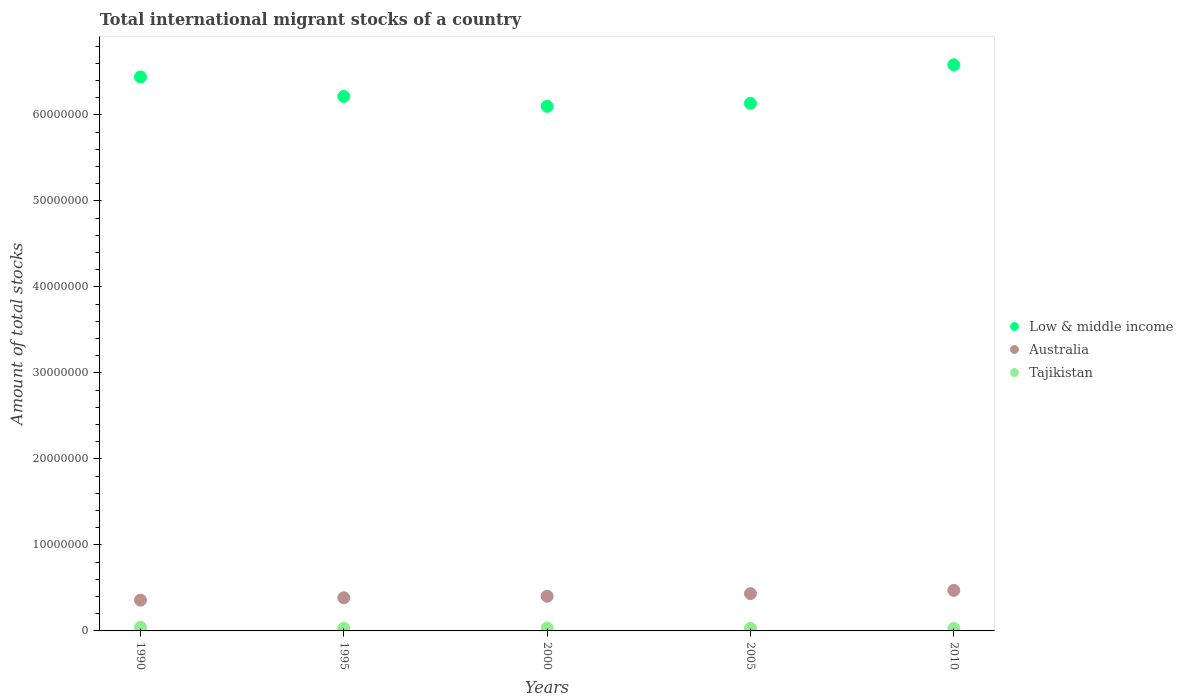Is the number of dotlines equal to the number of legend labels?
Offer a very short reply. Yes. What is the amount of total stocks in in Tajikistan in 1995?
Ensure brevity in your answer.  3.05e+05. Across all years, what is the maximum amount of total stocks in in Tajikistan?
Your answer should be compact. 4.26e+05. Across all years, what is the minimum amount of total stocks in in Australia?
Ensure brevity in your answer.  3.58e+06. In which year was the amount of total stocks in in Low & middle income maximum?
Your response must be concise. 2010. In which year was the amount of total stocks in in Low & middle income minimum?
Ensure brevity in your answer.  2000. What is the total amount of total stocks in in Tajikistan in the graph?
Make the answer very short. 1.65e+06. What is the difference between the amount of total stocks in in Low & middle income in 1995 and that in 2010?
Offer a very short reply. -3.68e+06. What is the difference between the amount of total stocks in in Low & middle income in 2000 and the amount of total stocks in in Australia in 2010?
Provide a short and direct response. 5.63e+07. What is the average amount of total stocks in in Tajikistan per year?
Make the answer very short. 3.30e+05. In the year 2000, what is the difference between the amount of total stocks in in Tajikistan and amount of total stocks in in Australia?
Provide a succinct answer. -3.70e+06. In how many years, is the amount of total stocks in in Australia greater than 46000000?
Give a very brief answer. 0. What is the ratio of the amount of total stocks in in Low & middle income in 1990 to that in 2000?
Give a very brief answer. 1.06. Is the amount of total stocks in in Tajikistan in 2000 less than that in 2010?
Provide a short and direct response. No. Is the difference between the amount of total stocks in in Tajikistan in 2000 and 2010 greater than the difference between the amount of total stocks in in Australia in 2000 and 2010?
Ensure brevity in your answer.  Yes. What is the difference between the highest and the second highest amount of total stocks in in Tajikistan?
Your response must be concise. 9.56e+04. What is the difference between the highest and the lowest amount of total stocks in in Tajikistan?
Keep it short and to the point. 1.42e+05. Is the sum of the amount of total stocks in in Australia in 2000 and 2010 greater than the maximum amount of total stocks in in Tajikistan across all years?
Give a very brief answer. Yes. Is it the case that in every year, the sum of the amount of total stocks in in Tajikistan and amount of total stocks in in Low & middle income  is greater than the amount of total stocks in in Australia?
Ensure brevity in your answer.  Yes. Does the amount of total stocks in in Low & middle income monotonically increase over the years?
Offer a terse response. No. Is the amount of total stocks in in Tajikistan strictly greater than the amount of total stocks in in Low & middle income over the years?
Provide a succinct answer. No. How many dotlines are there?
Give a very brief answer. 3. Does the graph contain grids?
Offer a very short reply. No. How many legend labels are there?
Ensure brevity in your answer.  3. How are the legend labels stacked?
Provide a succinct answer. Vertical. What is the title of the graph?
Offer a terse response. Total international migrant stocks of a country. What is the label or title of the Y-axis?
Offer a terse response. Amount of total stocks. What is the Amount of total stocks in Low & middle income in 1990?
Make the answer very short. 6.44e+07. What is the Amount of total stocks of Australia in 1990?
Your answer should be compact. 3.58e+06. What is the Amount of total stocks of Tajikistan in 1990?
Offer a terse response. 4.26e+05. What is the Amount of total stocks in Low & middle income in 1995?
Give a very brief answer. 6.21e+07. What is the Amount of total stocks in Australia in 1995?
Offer a terse response. 3.85e+06. What is the Amount of total stocks in Tajikistan in 1995?
Provide a short and direct response. 3.05e+05. What is the Amount of total stocks in Low & middle income in 2000?
Give a very brief answer. 6.10e+07. What is the Amount of total stocks of Australia in 2000?
Provide a succinct answer. 4.03e+06. What is the Amount of total stocks of Tajikistan in 2000?
Make the answer very short. 3.30e+05. What is the Amount of total stocks in Low & middle income in 2005?
Offer a terse response. 6.13e+07. What is the Amount of total stocks of Australia in 2005?
Provide a short and direct response. 4.34e+06. What is the Amount of total stocks in Tajikistan in 2005?
Give a very brief answer. 3.06e+05. What is the Amount of total stocks in Low & middle income in 2010?
Offer a very short reply. 6.58e+07. What is the Amount of total stocks of Australia in 2010?
Make the answer very short. 4.71e+06. What is the Amount of total stocks in Tajikistan in 2010?
Keep it short and to the point. 2.84e+05. Across all years, what is the maximum Amount of total stocks in Low & middle income?
Your answer should be very brief. 6.58e+07. Across all years, what is the maximum Amount of total stocks in Australia?
Give a very brief answer. 4.71e+06. Across all years, what is the maximum Amount of total stocks of Tajikistan?
Your answer should be compact. 4.26e+05. Across all years, what is the minimum Amount of total stocks of Low & middle income?
Your response must be concise. 6.10e+07. Across all years, what is the minimum Amount of total stocks of Australia?
Provide a succinct answer. 3.58e+06. Across all years, what is the minimum Amount of total stocks of Tajikistan?
Keep it short and to the point. 2.84e+05. What is the total Amount of total stocks of Low & middle income in the graph?
Make the answer very short. 3.15e+08. What is the total Amount of total stocks in Australia in the graph?
Your response must be concise. 2.05e+07. What is the total Amount of total stocks of Tajikistan in the graph?
Make the answer very short. 1.65e+06. What is the difference between the Amount of total stocks in Low & middle income in 1990 and that in 1995?
Ensure brevity in your answer.  2.26e+06. What is the difference between the Amount of total stocks of Australia in 1990 and that in 1995?
Your answer should be very brief. -2.72e+05. What is the difference between the Amount of total stocks of Tajikistan in 1990 and that in 1995?
Ensure brevity in your answer.  1.21e+05. What is the difference between the Amount of total stocks in Low & middle income in 1990 and that in 2000?
Provide a short and direct response. 3.41e+06. What is the difference between the Amount of total stocks in Australia in 1990 and that in 2000?
Keep it short and to the point. -4.46e+05. What is the difference between the Amount of total stocks of Tajikistan in 1990 and that in 2000?
Offer a terse response. 9.56e+04. What is the difference between the Amount of total stocks of Low & middle income in 1990 and that in 2005?
Your answer should be very brief. 3.07e+06. What is the difference between the Amount of total stocks in Australia in 1990 and that in 2005?
Keep it short and to the point. -7.54e+05. What is the difference between the Amount of total stocks of Tajikistan in 1990 and that in 2005?
Make the answer very short. 1.19e+05. What is the difference between the Amount of total stocks in Low & middle income in 1990 and that in 2010?
Keep it short and to the point. -1.42e+06. What is the difference between the Amount of total stocks in Australia in 1990 and that in 2010?
Offer a terse response. -1.13e+06. What is the difference between the Amount of total stocks in Tajikistan in 1990 and that in 2010?
Make the answer very short. 1.42e+05. What is the difference between the Amount of total stocks in Low & middle income in 1995 and that in 2000?
Your response must be concise. 1.15e+06. What is the difference between the Amount of total stocks in Australia in 1995 and that in 2000?
Keep it short and to the point. -1.74e+05. What is the difference between the Amount of total stocks in Tajikistan in 1995 and that in 2000?
Offer a very short reply. -2.54e+04. What is the difference between the Amount of total stocks in Low & middle income in 1995 and that in 2005?
Offer a terse response. 8.05e+05. What is the difference between the Amount of total stocks of Australia in 1995 and that in 2005?
Your answer should be compact. -4.82e+05. What is the difference between the Amount of total stocks in Tajikistan in 1995 and that in 2005?
Ensure brevity in your answer.  -1533. What is the difference between the Amount of total stocks of Low & middle income in 1995 and that in 2010?
Offer a very short reply. -3.68e+06. What is the difference between the Amount of total stocks in Australia in 1995 and that in 2010?
Offer a very short reply. -8.58e+05. What is the difference between the Amount of total stocks of Tajikistan in 1995 and that in 2010?
Provide a short and direct response. 2.06e+04. What is the difference between the Amount of total stocks of Low & middle income in 2000 and that in 2005?
Make the answer very short. -3.42e+05. What is the difference between the Amount of total stocks in Australia in 2000 and that in 2005?
Make the answer very short. -3.08e+05. What is the difference between the Amount of total stocks of Tajikistan in 2000 and that in 2005?
Offer a very short reply. 2.39e+04. What is the difference between the Amount of total stocks in Low & middle income in 2000 and that in 2010?
Your answer should be very brief. -4.83e+06. What is the difference between the Amount of total stocks in Australia in 2000 and that in 2010?
Provide a succinct answer. -6.84e+05. What is the difference between the Amount of total stocks in Tajikistan in 2000 and that in 2010?
Your response must be concise. 4.60e+04. What is the difference between the Amount of total stocks in Low & middle income in 2005 and that in 2010?
Provide a succinct answer. -4.49e+06. What is the difference between the Amount of total stocks in Australia in 2005 and that in 2010?
Your response must be concise. -3.76e+05. What is the difference between the Amount of total stocks in Tajikistan in 2005 and that in 2010?
Your answer should be very brief. 2.21e+04. What is the difference between the Amount of total stocks in Low & middle income in 1990 and the Amount of total stocks in Australia in 1995?
Your answer should be very brief. 6.06e+07. What is the difference between the Amount of total stocks in Low & middle income in 1990 and the Amount of total stocks in Tajikistan in 1995?
Provide a succinct answer. 6.41e+07. What is the difference between the Amount of total stocks in Australia in 1990 and the Amount of total stocks in Tajikistan in 1995?
Provide a short and direct response. 3.28e+06. What is the difference between the Amount of total stocks in Low & middle income in 1990 and the Amount of total stocks in Australia in 2000?
Your response must be concise. 6.04e+07. What is the difference between the Amount of total stocks in Low & middle income in 1990 and the Amount of total stocks in Tajikistan in 2000?
Your answer should be compact. 6.41e+07. What is the difference between the Amount of total stocks of Australia in 1990 and the Amount of total stocks of Tajikistan in 2000?
Give a very brief answer. 3.25e+06. What is the difference between the Amount of total stocks of Low & middle income in 1990 and the Amount of total stocks of Australia in 2005?
Keep it short and to the point. 6.01e+07. What is the difference between the Amount of total stocks in Low & middle income in 1990 and the Amount of total stocks in Tajikistan in 2005?
Keep it short and to the point. 6.41e+07. What is the difference between the Amount of total stocks of Australia in 1990 and the Amount of total stocks of Tajikistan in 2005?
Offer a very short reply. 3.27e+06. What is the difference between the Amount of total stocks of Low & middle income in 1990 and the Amount of total stocks of Australia in 2010?
Provide a succinct answer. 5.97e+07. What is the difference between the Amount of total stocks of Low & middle income in 1990 and the Amount of total stocks of Tajikistan in 2010?
Give a very brief answer. 6.41e+07. What is the difference between the Amount of total stocks of Australia in 1990 and the Amount of total stocks of Tajikistan in 2010?
Ensure brevity in your answer.  3.30e+06. What is the difference between the Amount of total stocks of Low & middle income in 1995 and the Amount of total stocks of Australia in 2000?
Provide a short and direct response. 5.81e+07. What is the difference between the Amount of total stocks of Low & middle income in 1995 and the Amount of total stocks of Tajikistan in 2000?
Ensure brevity in your answer.  6.18e+07. What is the difference between the Amount of total stocks in Australia in 1995 and the Amount of total stocks in Tajikistan in 2000?
Your response must be concise. 3.52e+06. What is the difference between the Amount of total stocks in Low & middle income in 1995 and the Amount of total stocks in Australia in 2005?
Offer a very short reply. 5.78e+07. What is the difference between the Amount of total stocks in Low & middle income in 1995 and the Amount of total stocks in Tajikistan in 2005?
Your answer should be compact. 6.18e+07. What is the difference between the Amount of total stocks of Australia in 1995 and the Amount of total stocks of Tajikistan in 2005?
Give a very brief answer. 3.55e+06. What is the difference between the Amount of total stocks of Low & middle income in 1995 and the Amount of total stocks of Australia in 2010?
Your answer should be compact. 5.74e+07. What is the difference between the Amount of total stocks of Low & middle income in 1995 and the Amount of total stocks of Tajikistan in 2010?
Offer a very short reply. 6.19e+07. What is the difference between the Amount of total stocks in Australia in 1995 and the Amount of total stocks in Tajikistan in 2010?
Offer a terse response. 3.57e+06. What is the difference between the Amount of total stocks of Low & middle income in 2000 and the Amount of total stocks of Australia in 2005?
Ensure brevity in your answer.  5.67e+07. What is the difference between the Amount of total stocks of Low & middle income in 2000 and the Amount of total stocks of Tajikistan in 2005?
Keep it short and to the point. 6.07e+07. What is the difference between the Amount of total stocks in Australia in 2000 and the Amount of total stocks in Tajikistan in 2005?
Your answer should be compact. 3.72e+06. What is the difference between the Amount of total stocks in Low & middle income in 2000 and the Amount of total stocks in Australia in 2010?
Your answer should be very brief. 5.63e+07. What is the difference between the Amount of total stocks in Low & middle income in 2000 and the Amount of total stocks in Tajikistan in 2010?
Provide a short and direct response. 6.07e+07. What is the difference between the Amount of total stocks of Australia in 2000 and the Amount of total stocks of Tajikistan in 2010?
Offer a very short reply. 3.74e+06. What is the difference between the Amount of total stocks in Low & middle income in 2005 and the Amount of total stocks in Australia in 2010?
Give a very brief answer. 5.66e+07. What is the difference between the Amount of total stocks in Low & middle income in 2005 and the Amount of total stocks in Tajikistan in 2010?
Your response must be concise. 6.11e+07. What is the difference between the Amount of total stocks in Australia in 2005 and the Amount of total stocks in Tajikistan in 2010?
Your response must be concise. 4.05e+06. What is the average Amount of total stocks in Low & middle income per year?
Your answer should be compact. 6.29e+07. What is the average Amount of total stocks of Australia per year?
Keep it short and to the point. 4.10e+06. What is the average Amount of total stocks of Tajikistan per year?
Ensure brevity in your answer.  3.30e+05. In the year 1990, what is the difference between the Amount of total stocks in Low & middle income and Amount of total stocks in Australia?
Your response must be concise. 6.08e+07. In the year 1990, what is the difference between the Amount of total stocks in Low & middle income and Amount of total stocks in Tajikistan?
Offer a very short reply. 6.40e+07. In the year 1990, what is the difference between the Amount of total stocks of Australia and Amount of total stocks of Tajikistan?
Give a very brief answer. 3.16e+06. In the year 1995, what is the difference between the Amount of total stocks of Low & middle income and Amount of total stocks of Australia?
Give a very brief answer. 5.83e+07. In the year 1995, what is the difference between the Amount of total stocks in Low & middle income and Amount of total stocks in Tajikistan?
Keep it short and to the point. 6.18e+07. In the year 1995, what is the difference between the Amount of total stocks in Australia and Amount of total stocks in Tajikistan?
Ensure brevity in your answer.  3.55e+06. In the year 2000, what is the difference between the Amount of total stocks of Low & middle income and Amount of total stocks of Australia?
Give a very brief answer. 5.70e+07. In the year 2000, what is the difference between the Amount of total stocks of Low & middle income and Amount of total stocks of Tajikistan?
Your answer should be very brief. 6.07e+07. In the year 2000, what is the difference between the Amount of total stocks in Australia and Amount of total stocks in Tajikistan?
Offer a very short reply. 3.70e+06. In the year 2005, what is the difference between the Amount of total stocks of Low & middle income and Amount of total stocks of Australia?
Provide a succinct answer. 5.70e+07. In the year 2005, what is the difference between the Amount of total stocks of Low & middle income and Amount of total stocks of Tajikistan?
Your response must be concise. 6.10e+07. In the year 2005, what is the difference between the Amount of total stocks in Australia and Amount of total stocks in Tajikistan?
Provide a short and direct response. 4.03e+06. In the year 2010, what is the difference between the Amount of total stocks in Low & middle income and Amount of total stocks in Australia?
Your answer should be compact. 6.11e+07. In the year 2010, what is the difference between the Amount of total stocks in Low & middle income and Amount of total stocks in Tajikistan?
Make the answer very short. 6.55e+07. In the year 2010, what is the difference between the Amount of total stocks of Australia and Amount of total stocks of Tajikistan?
Offer a terse response. 4.43e+06. What is the ratio of the Amount of total stocks in Low & middle income in 1990 to that in 1995?
Your answer should be compact. 1.04. What is the ratio of the Amount of total stocks in Australia in 1990 to that in 1995?
Give a very brief answer. 0.93. What is the ratio of the Amount of total stocks of Tajikistan in 1990 to that in 1995?
Your answer should be very brief. 1.4. What is the ratio of the Amount of total stocks in Low & middle income in 1990 to that in 2000?
Make the answer very short. 1.06. What is the ratio of the Amount of total stocks in Australia in 1990 to that in 2000?
Ensure brevity in your answer.  0.89. What is the ratio of the Amount of total stocks of Tajikistan in 1990 to that in 2000?
Keep it short and to the point. 1.29. What is the ratio of the Amount of total stocks of Low & middle income in 1990 to that in 2005?
Your answer should be compact. 1.05. What is the ratio of the Amount of total stocks in Australia in 1990 to that in 2005?
Make the answer very short. 0.83. What is the ratio of the Amount of total stocks in Tajikistan in 1990 to that in 2005?
Keep it short and to the point. 1.39. What is the ratio of the Amount of total stocks of Low & middle income in 1990 to that in 2010?
Provide a short and direct response. 0.98. What is the ratio of the Amount of total stocks of Australia in 1990 to that in 2010?
Offer a very short reply. 0.76. What is the ratio of the Amount of total stocks in Tajikistan in 1990 to that in 2010?
Offer a terse response. 1.5. What is the ratio of the Amount of total stocks of Low & middle income in 1995 to that in 2000?
Give a very brief answer. 1.02. What is the ratio of the Amount of total stocks in Australia in 1995 to that in 2000?
Provide a succinct answer. 0.96. What is the ratio of the Amount of total stocks in Tajikistan in 1995 to that in 2000?
Your response must be concise. 0.92. What is the ratio of the Amount of total stocks of Low & middle income in 1995 to that in 2005?
Your response must be concise. 1.01. What is the ratio of the Amount of total stocks of Australia in 1995 to that in 2005?
Your answer should be very brief. 0.89. What is the ratio of the Amount of total stocks of Low & middle income in 1995 to that in 2010?
Provide a succinct answer. 0.94. What is the ratio of the Amount of total stocks in Australia in 1995 to that in 2010?
Provide a succinct answer. 0.82. What is the ratio of the Amount of total stocks in Tajikistan in 1995 to that in 2010?
Make the answer very short. 1.07. What is the ratio of the Amount of total stocks in Low & middle income in 2000 to that in 2005?
Offer a very short reply. 0.99. What is the ratio of the Amount of total stocks in Australia in 2000 to that in 2005?
Offer a very short reply. 0.93. What is the ratio of the Amount of total stocks in Tajikistan in 2000 to that in 2005?
Provide a short and direct response. 1.08. What is the ratio of the Amount of total stocks in Low & middle income in 2000 to that in 2010?
Your answer should be compact. 0.93. What is the ratio of the Amount of total stocks in Australia in 2000 to that in 2010?
Offer a very short reply. 0.85. What is the ratio of the Amount of total stocks in Tajikistan in 2000 to that in 2010?
Provide a short and direct response. 1.16. What is the ratio of the Amount of total stocks in Low & middle income in 2005 to that in 2010?
Make the answer very short. 0.93. What is the ratio of the Amount of total stocks of Australia in 2005 to that in 2010?
Your answer should be compact. 0.92. What is the ratio of the Amount of total stocks in Tajikistan in 2005 to that in 2010?
Make the answer very short. 1.08. What is the difference between the highest and the second highest Amount of total stocks in Low & middle income?
Offer a terse response. 1.42e+06. What is the difference between the highest and the second highest Amount of total stocks in Australia?
Your answer should be very brief. 3.76e+05. What is the difference between the highest and the second highest Amount of total stocks of Tajikistan?
Ensure brevity in your answer.  9.56e+04. What is the difference between the highest and the lowest Amount of total stocks of Low & middle income?
Offer a terse response. 4.83e+06. What is the difference between the highest and the lowest Amount of total stocks of Australia?
Give a very brief answer. 1.13e+06. What is the difference between the highest and the lowest Amount of total stocks in Tajikistan?
Offer a very short reply. 1.42e+05. 